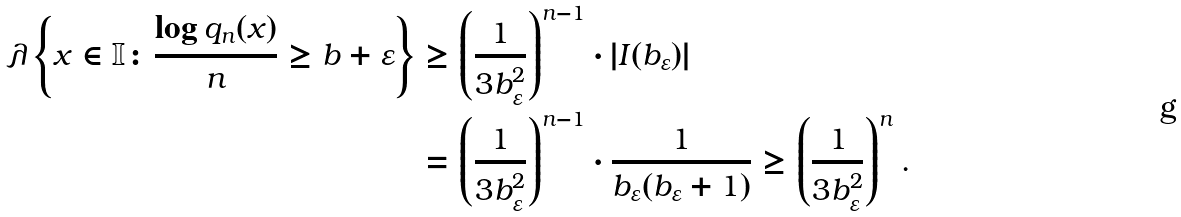Convert formula to latex. <formula><loc_0><loc_0><loc_500><loc_500>\lambda \left \{ x \in \mathbb { I } \colon \frac { \log q _ { n } ( x ) } { n } \geq b + \varepsilon \right \} & \geq \left ( \frac { 1 } { 3 b _ { \varepsilon } ^ { 2 } } \right ) ^ { n - 1 } \cdot | I ( b _ { \varepsilon } ) | \\ & = \left ( \frac { 1 } { 3 b _ { \varepsilon } ^ { 2 } } \right ) ^ { n - 1 } \cdot \frac { 1 } { b _ { \varepsilon } ( b _ { \varepsilon } + 1 ) } \geq \left ( \frac { 1 } { 3 b _ { \varepsilon } ^ { 2 } } \right ) ^ { n } .</formula> 